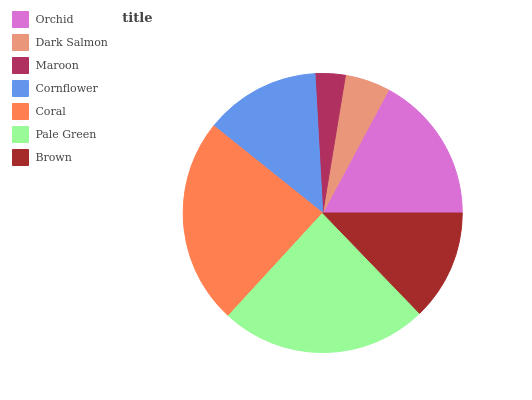Is Maroon the minimum?
Answer yes or no. Yes. Is Pale Green the maximum?
Answer yes or no. Yes. Is Dark Salmon the minimum?
Answer yes or no. No. Is Dark Salmon the maximum?
Answer yes or no. No. Is Orchid greater than Dark Salmon?
Answer yes or no. Yes. Is Dark Salmon less than Orchid?
Answer yes or no. Yes. Is Dark Salmon greater than Orchid?
Answer yes or no. No. Is Orchid less than Dark Salmon?
Answer yes or no. No. Is Cornflower the high median?
Answer yes or no. Yes. Is Cornflower the low median?
Answer yes or no. Yes. Is Maroon the high median?
Answer yes or no. No. Is Dark Salmon the low median?
Answer yes or no. No. 